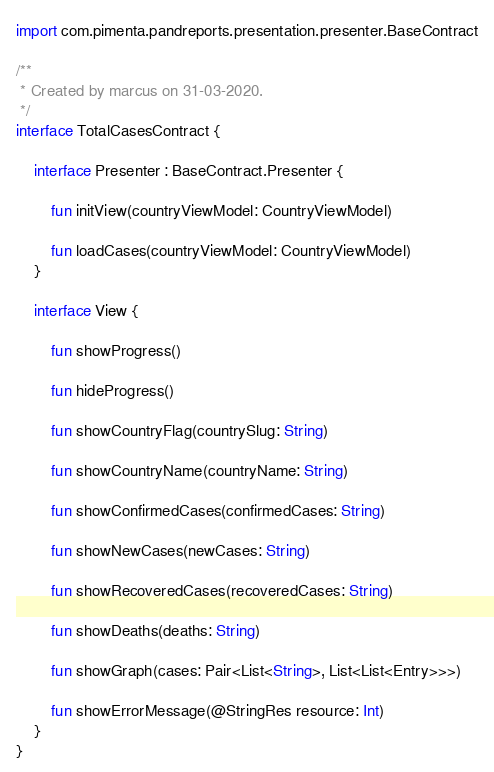<code> <loc_0><loc_0><loc_500><loc_500><_Kotlin_>import com.pimenta.pandreports.presentation.presenter.BaseContract

/**
 * Created by marcus on 31-03-2020.
 */
interface TotalCasesContract {

    interface Presenter : BaseContract.Presenter {

        fun initView(countryViewModel: CountryViewModel)

        fun loadCases(countryViewModel: CountryViewModel)
    }

    interface View {

        fun showProgress()

        fun hideProgress()

        fun showCountryFlag(countrySlug: String)

        fun showCountryName(countryName: String)

        fun showConfirmedCases(confirmedCases: String)

        fun showNewCases(newCases: String)

        fun showRecoveredCases(recoveredCases: String)

        fun showDeaths(deaths: String)

        fun showGraph(cases: Pair<List<String>, List<List<Entry>>>)

        fun showErrorMessage(@StringRes resource: Int)
    }
}</code> 